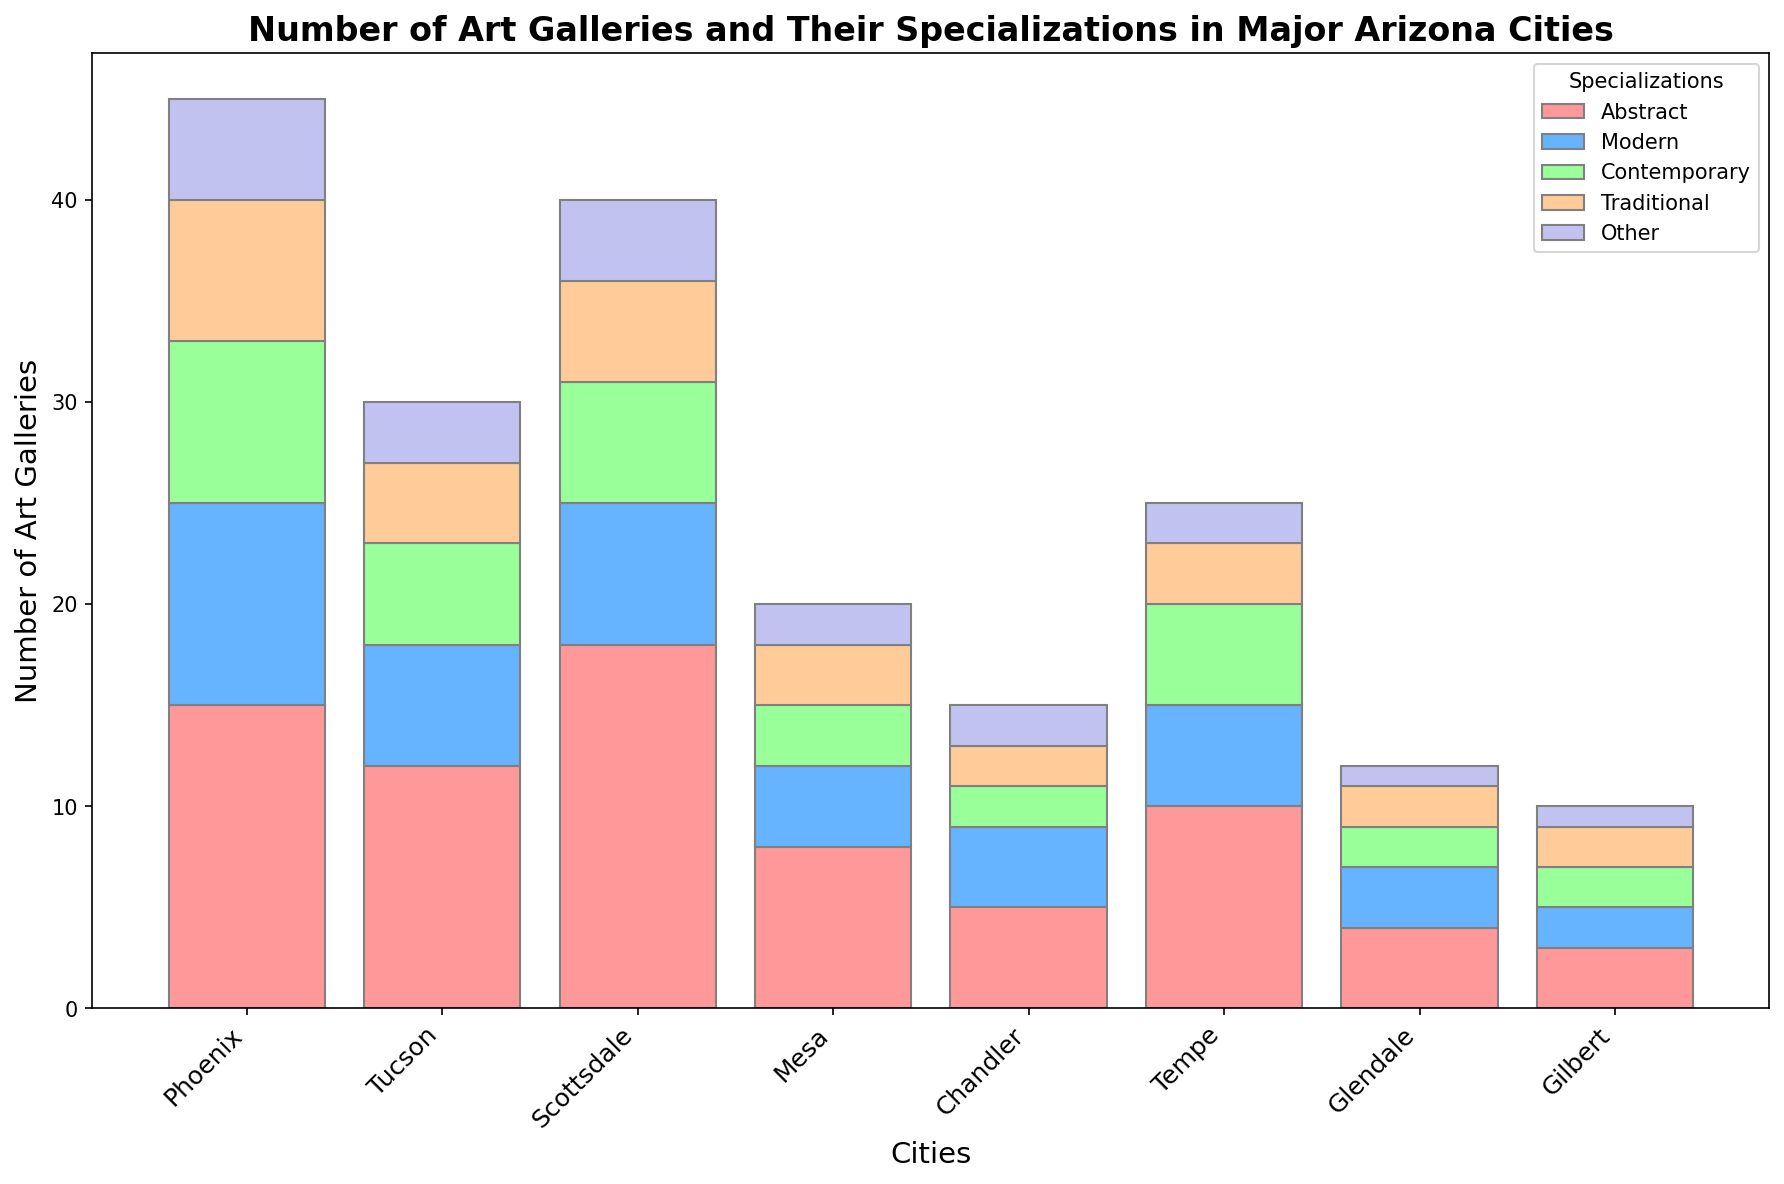What city has the highest number of art galleries specializing in Abstract art? Scottsdale has the highest number of art galleries specializing in Abstract art with 18 galleries. To find this, look for the tallest red segment (Abstract) in each city's stacked bar.
Answer: Scottsdale Which city has more art galleries, Tempe or Mesa? Tempe has 25 art galleries while Mesa has 20. Compare the total heights of the stacked bars for both cities to determine this.
Answer: Tempe Which specialization is least common in Chandler? Look at the segments for Chandler to see which color is smallest. The smallest segments are Contemporary, Traditional, and Other, each with 2 galleries.
Answer: Contemporary, Traditional, and Other How many total art galleries are there across all cities? Sum the total number of art galleries from all cities: 45 (Phoenix) + 30 (Tucson) + 40 (Scottsdale) + 20 (Mesa) + 15 (Chandler) + 25 (Tempe) + 12 (Glendale) + 10 (Gilbert) = 197.
Answer: 197 Which city has the same number of galleries specializing in Modern and Contemporary art? Look for a city where the blue (Modern) and green (Contemporary) segments are of equal height. Both specialties in Phoenix have 10 galleries each.
Answer: Phoenix What is the total number of galleries specializing in Modern art across all cities? Add the number of Modern art galleries in each city: 10 (Phoenix) + 6 (Tucson) + 7 (Scottsdale) + 4 (Mesa) + 4 (Chandler) + 5 (Tempe) + 3 (Glendale) + 2 (Gilbert) = 41.
Answer: 41 If you combine the number of galleries specializing in Abstract and Contemporary art, which city has the highest total? Add the number of Abstract and Contemporary galleries for each city and compare: Phoenix (15+8=23), Tucson (12+5=17), Scottsdale (18+6=24), Mesa (8+3=11), Chandler (5+2=7), Tempe (10+5=15), Glendale (4+2=6), Gilbert (3+2=5). Scottsdale has the highest total with 24.
Answer: Scottsdale Which city has the fewest galleries specializing in Traditional art? Compare the height of the orange segments (Traditional) in each city. Several cities (Mesa, Chandler, Glendale, and Gilbert) have 2 galleries each.
Answer: Mesa, Chandler, Glendale, and Gilbert What is the difference in the total number of art galleries between the city with the most and the city with the fewest galleries? The city with the most galleries is Phoenix (45) and the city with the fewest is Gilbert (10). The difference is 45 - 10 = 35.
Answer: 35 Which city has more galleries specializing in Contemporary art, Tempe or Tucson? Compare the green segments (Contemporary) for both cities. Tempe has 5 galleries and Tucson has 5. So they have an equal number.
Answer: Equal 